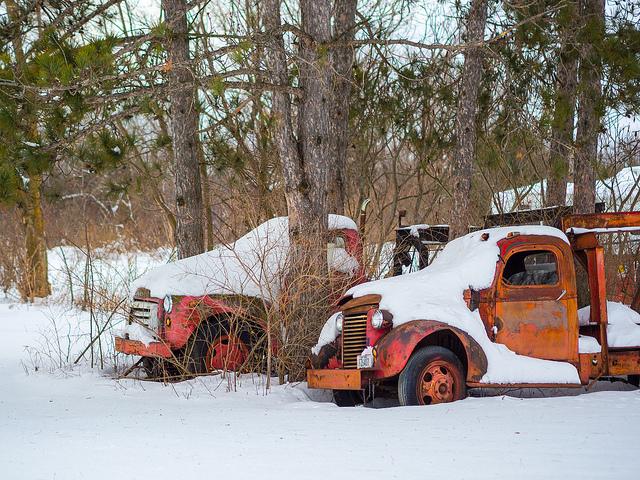Do the trucks have rust on them?
Give a very brief answer. Yes. Are the trucks going to race in the snow?
Quick response, please. No. Are the trucks parked under a tree?
Concise answer only. Yes. 